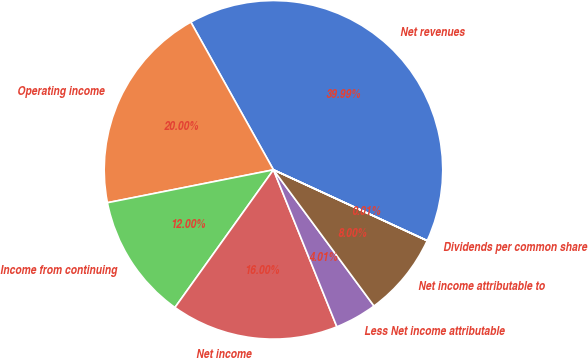Convert chart to OTSL. <chart><loc_0><loc_0><loc_500><loc_500><pie_chart><fcel>Net revenues<fcel>Operating income<fcel>Income from continuing<fcel>Net income<fcel>Less Net income attributable<fcel>Net income attributable to<fcel>Dividends per common share<nl><fcel>39.99%<fcel>20.0%<fcel>12.0%<fcel>16.0%<fcel>4.01%<fcel>8.0%<fcel>0.01%<nl></chart> 